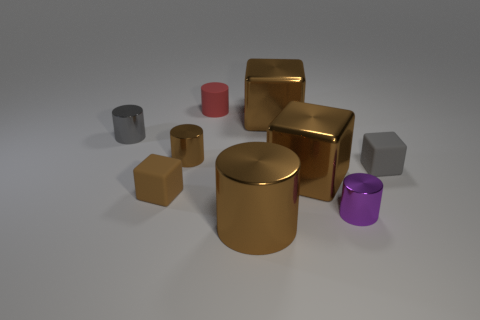There is a metal cube that is right of the cube behind the gray metal object; is there a small gray thing behind it? Yes, there is a small gray cylinder located behind the large metal cube that is situated to the right of another cube, which in turn is behind the gray metal object. 